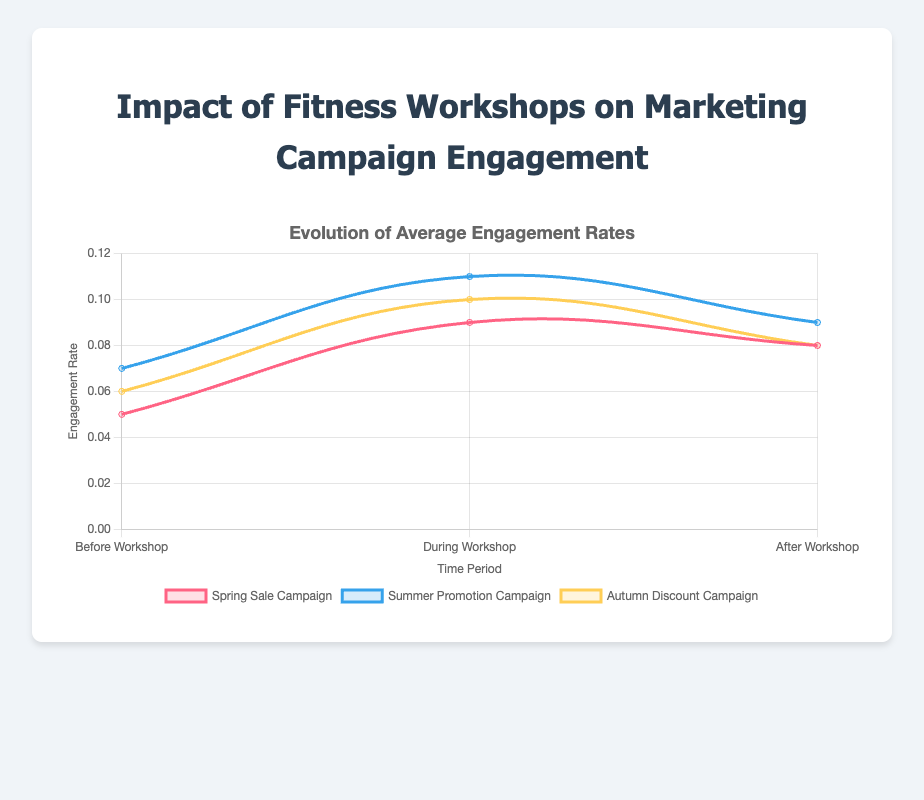What is the engagement rate of the 'Summer Promotion Campaign' during the workshop? Look at the 'Summer Promotion Campaign' line on the chart during the workshop period. The engagement rate is marked at 0.11.
Answer: 0.11 How does the engagement rate of the 'Spring Sale Campaign' change from before to after the workshop? Identify the 'Spring Sale Campaign' line. The engagement rate increases from 0.05 before the workshop to 0.08 after the workshop. Calculate the difference: 0.08 - 0.05.
Answer: Increased by 0.03 Which campaign shows the highest engagement rate during the workshop? Compare the peaks during the workshop for each campaign line. 'Summer Promotion Campaign' has the highest rate at 0.11.
Answer: Summer Promotion Campaign What is the average engagement rate for the 'Autumn Discount Campaign' across all time periods? Add up the engagement rates for 'Autumn Discount Campaign': 0.06 (before) + 0.10 (during) + 0.08 (after). Then divide by 3 to find the average: (0.06 + 0.10 + 0.08) / 3.
Answer: 0.08 Which time period shows the highest average engagement rate across all campaigns? Calculate the average rate for each period: Before: (0.05 + 0.07 + 0.06) / 3 = 0.06; During: (0.09 + 0.11 + 0.10) / 3 = 0.10; After: (0.08 + 0.09 + 0.08) / 3 = 0.083. The 'During Workshop' period has the highest average.
Answer: During Workshop By how much did the engagement rate of the 'Autumn Discount Campaign' increase during the workshop compared to before? Subtract the 'before' rate from the 'during' rate for 'Autumn Discount Campaign': 0.10 - 0.06.
Answer: Increased by 0.04 Which campaign had the smallest increase in engagement rate during the workshop compared to before? Calculate the increases: 'Spring Sale' (0.09 - 0.05 = 0.04), 'Summer Promotion' (0.11 - 0.07 = 0.04), 'Autumn Discount' (0.10 - 0.06 = 0.04). All campaigns had the same increase.
Answer: All campaigns Is there any campaign that maintained the same engagement rate after the workshop as during the workshop? Compare the 'during' and 'after' engagement rates for each campaign. None of the campaigns have the same rates for these periods.
Answer: No 